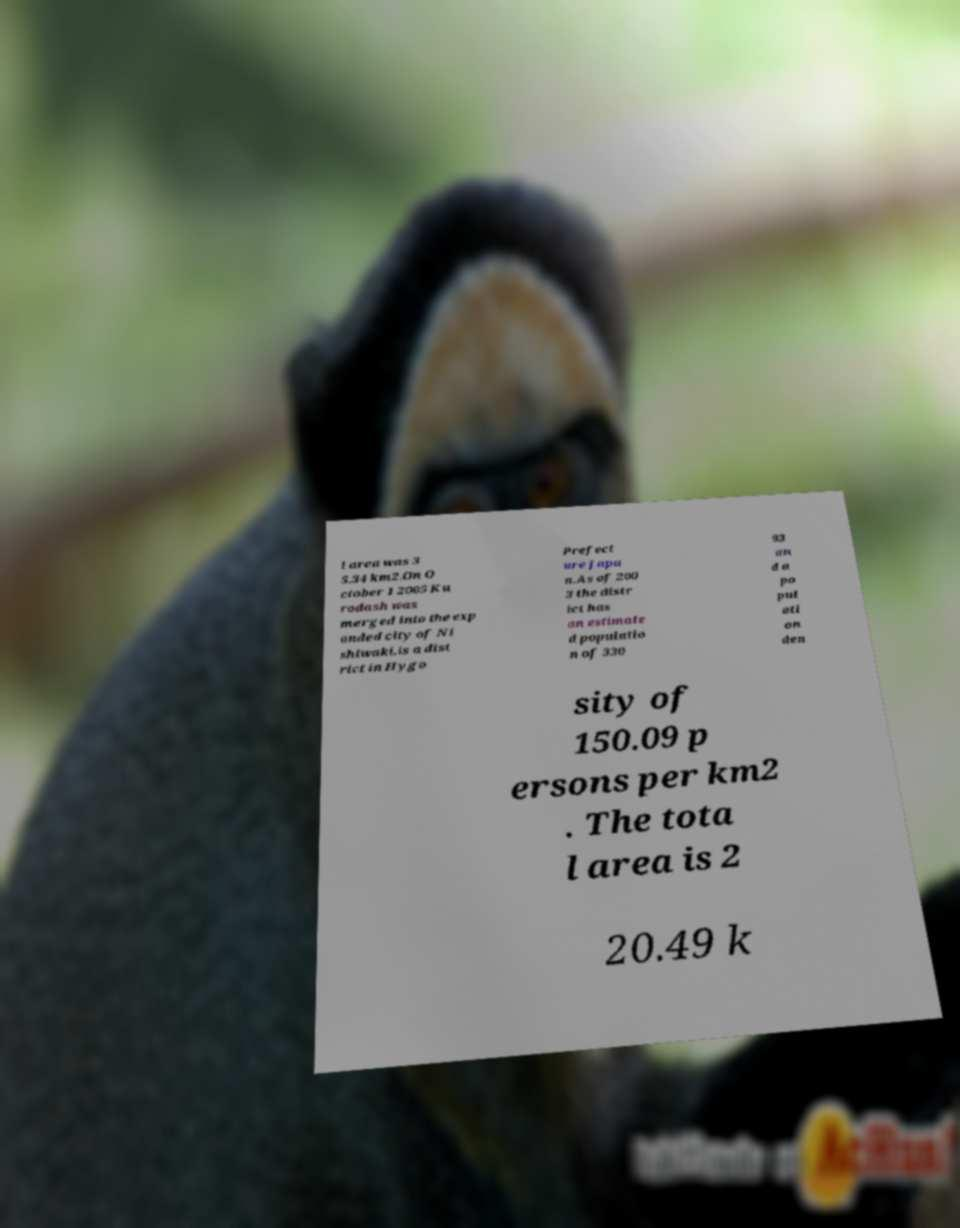Please read and relay the text visible in this image. What does it say? l area was 3 5.34 km2.On O ctober 1 2005 Ku rodash was merged into the exp anded city of Ni shiwaki.is a dist rict in Hygo Prefect ure Japa n.As of 200 3 the distr ict has an estimate d populatio n of 330 93 an d a po pul ati on den sity of 150.09 p ersons per km2 . The tota l area is 2 20.49 k 